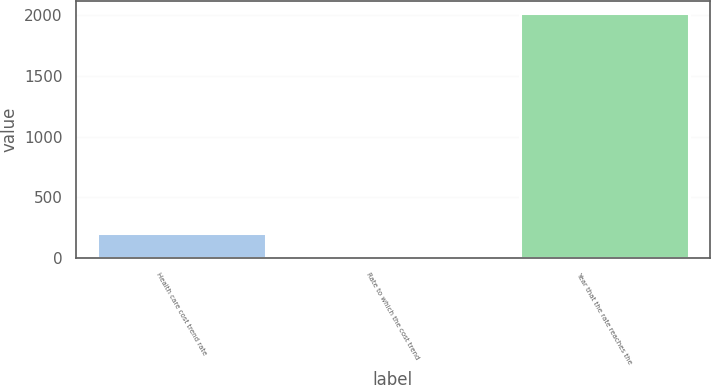Convert chart. <chart><loc_0><loc_0><loc_500><loc_500><bar_chart><fcel>Health care cost trend rate<fcel>Rate to which the cost trend<fcel>Year that the rate reaches the<nl><fcel>205.95<fcel>4.5<fcel>2019<nl></chart> 